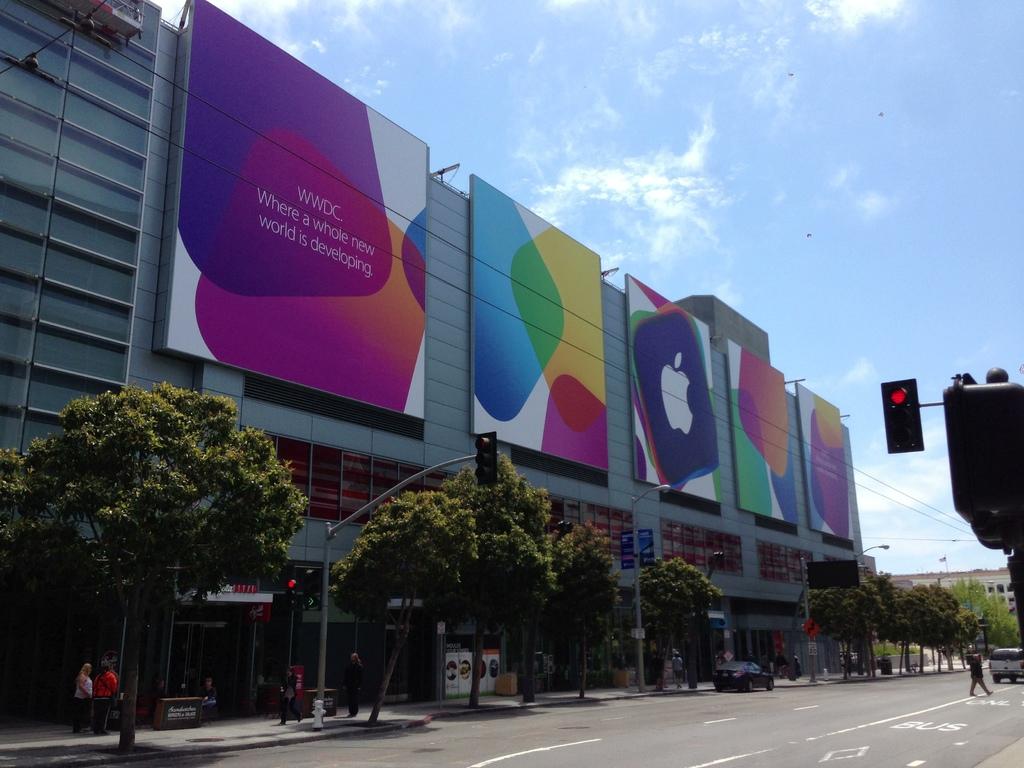What does it say on the first billboard?
Your answer should be very brief. Wwdc where a whole new world is developing. 